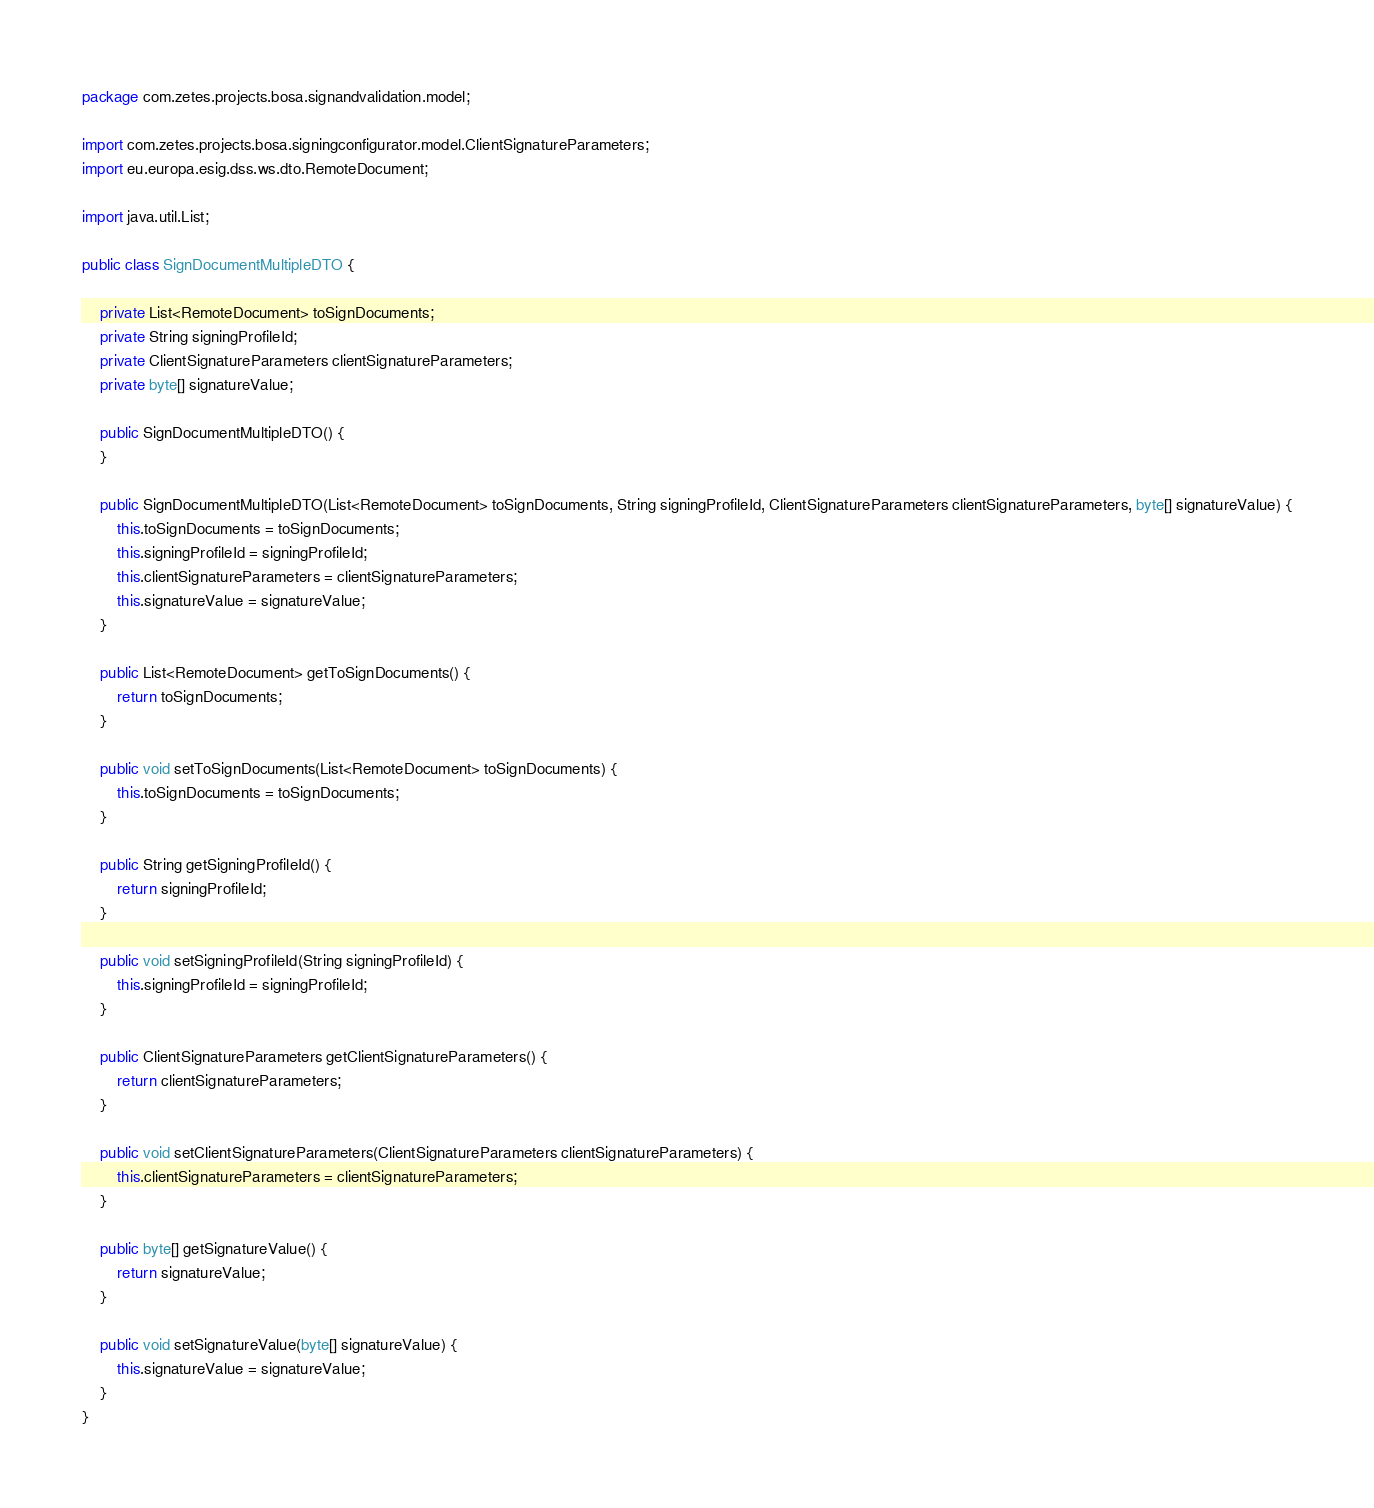Convert code to text. <code><loc_0><loc_0><loc_500><loc_500><_Java_>package com.zetes.projects.bosa.signandvalidation.model;

import com.zetes.projects.bosa.signingconfigurator.model.ClientSignatureParameters;
import eu.europa.esig.dss.ws.dto.RemoteDocument;

import java.util.List;

public class SignDocumentMultipleDTO {

    private List<RemoteDocument> toSignDocuments;
    private String signingProfileId;
    private ClientSignatureParameters clientSignatureParameters;
    private byte[] signatureValue;

    public SignDocumentMultipleDTO() {
    }

    public SignDocumentMultipleDTO(List<RemoteDocument> toSignDocuments, String signingProfileId, ClientSignatureParameters clientSignatureParameters, byte[] signatureValue) {
        this.toSignDocuments = toSignDocuments;
        this.signingProfileId = signingProfileId;
        this.clientSignatureParameters = clientSignatureParameters;
        this.signatureValue = signatureValue;
    }

    public List<RemoteDocument> getToSignDocuments() {
        return toSignDocuments;
    }

    public void setToSignDocuments(List<RemoteDocument> toSignDocuments) {
        this.toSignDocuments = toSignDocuments;
    }

    public String getSigningProfileId() {
        return signingProfileId;
    }

    public void setSigningProfileId(String signingProfileId) {
        this.signingProfileId = signingProfileId;
    }

    public ClientSignatureParameters getClientSignatureParameters() {
        return clientSignatureParameters;
    }

    public void setClientSignatureParameters(ClientSignatureParameters clientSignatureParameters) {
        this.clientSignatureParameters = clientSignatureParameters;
    }

    public byte[] getSignatureValue() {
        return signatureValue;
    }

    public void setSignatureValue(byte[] signatureValue) {
        this.signatureValue = signatureValue;
    }
}
</code> 